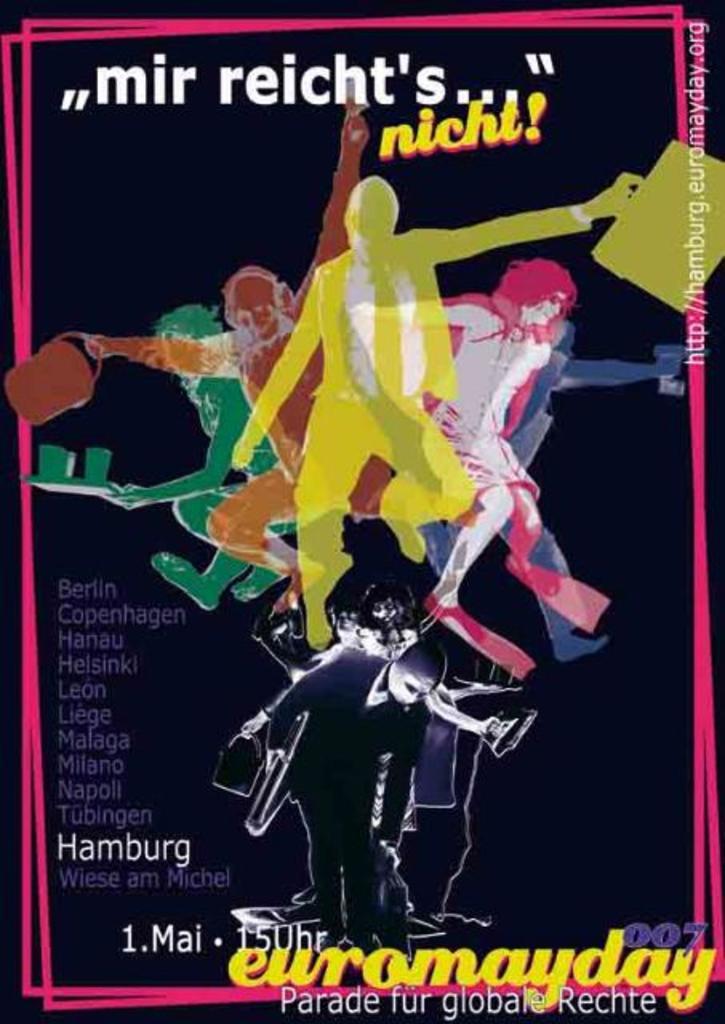Which city is on the poster?
Your answer should be compact. Hamburg. 